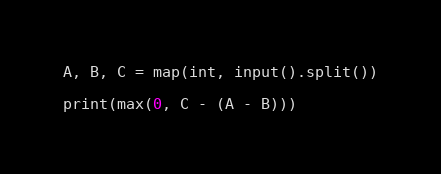<code> <loc_0><loc_0><loc_500><loc_500><_Python_>A, B, C = map(int, input().split())

print(max(0, C - (A - B)))</code> 